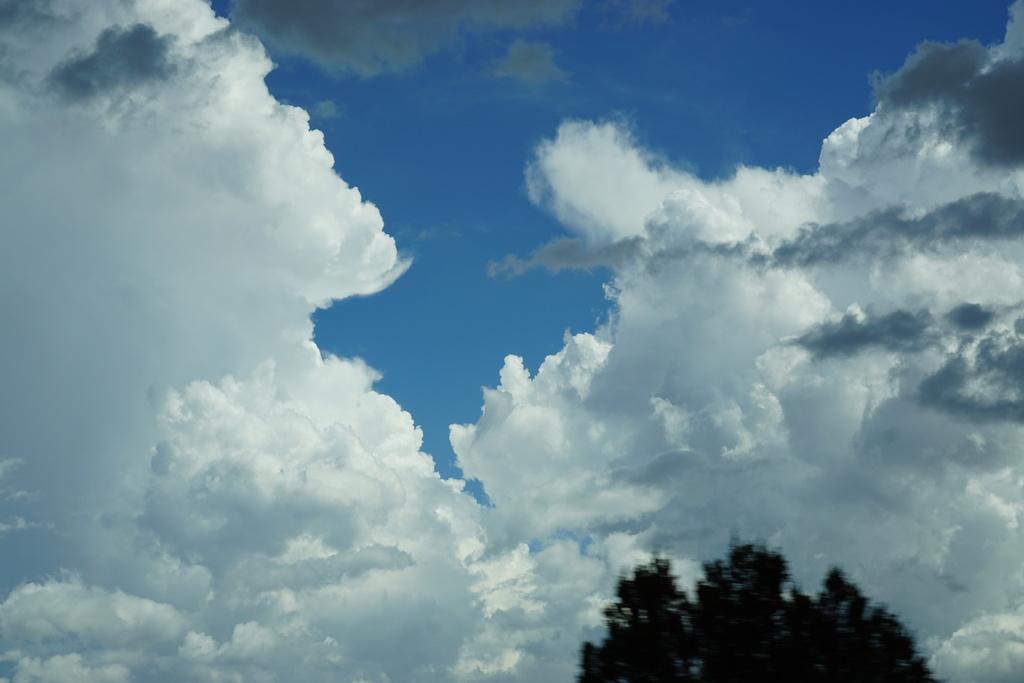Can you describe this image briefly? This picture shows a tree and a blue cloudy sky. 